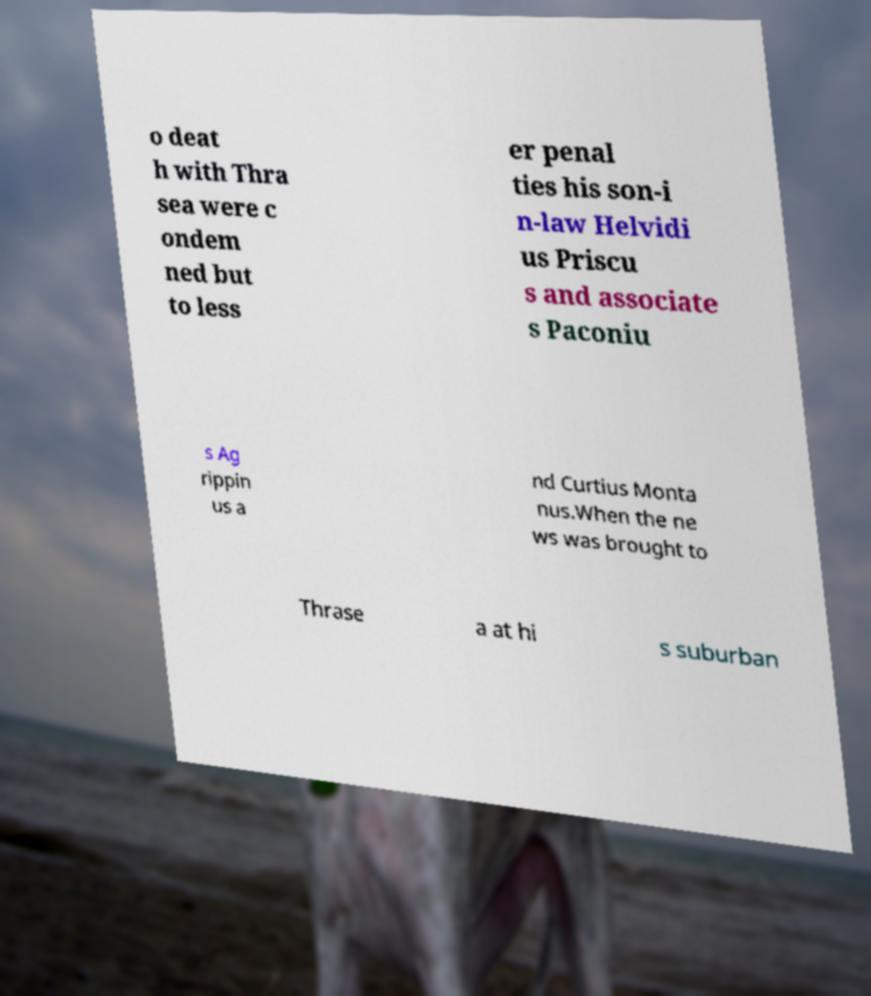Can you accurately transcribe the text from the provided image for me? o deat h with Thra sea were c ondem ned but to less er penal ties his son-i n-law Helvidi us Priscu s and associate s Paconiu s Ag rippin us a nd Curtius Monta nus.When the ne ws was brought to Thrase a at hi s suburban 